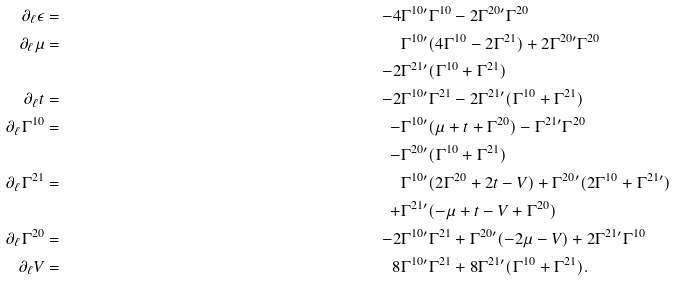Convert formula to latex. <formula><loc_0><loc_0><loc_500><loc_500>\partial _ { \ell } \epsilon & = \, & \, - 4 & \Gamma ^ { 1 0 \prime } \Gamma ^ { 1 0 } - 2 \Gamma ^ { 2 0 \prime } \Gamma ^ { 2 0 } \\ \partial _ { \ell } \mu & = \, & \, & \Gamma ^ { 1 0 \prime } ( 4 \Gamma ^ { 1 0 } - 2 \Gamma ^ { 2 1 } ) + 2 \Gamma ^ { 2 0 \prime } \Gamma ^ { 2 0 } \\ & \, & \, - 2 & \Gamma ^ { 2 1 \prime } ( \Gamma ^ { 1 0 } + \Gamma ^ { 2 1 } ) \\ \partial _ { \ell } t & = \, & \, - 2 & \Gamma ^ { 1 0 \prime } \Gamma ^ { 2 1 } - 2 \Gamma ^ { 2 1 \prime } ( \Gamma ^ { 1 0 } + \Gamma ^ { 2 1 } ) \\ \partial _ { \ell } \Gamma ^ { 1 0 } & = \, & \, - & \Gamma ^ { 1 0 \prime } ( \mu + t + \Gamma ^ { 2 0 } ) - \Gamma ^ { 2 1 \prime } \Gamma ^ { 2 0 } \\ & \, & \, - & \Gamma ^ { 2 0 \prime } ( \Gamma ^ { 1 0 } + \Gamma ^ { 2 1 } ) \\ \partial _ { \ell } \Gamma ^ { 2 1 } & = \, & \, & \Gamma ^ { 1 0 \prime } ( 2 \Gamma ^ { 2 0 } + 2 t - V ) + \Gamma ^ { 2 0 \prime } ( 2 \Gamma ^ { 1 0 } + \Gamma ^ { 2 1 \prime } ) \\ & \, & \, + & \Gamma ^ { 2 1 \prime } ( - \mu + t - V + \Gamma ^ { 2 0 } ) \\ \partial _ { \ell } \Gamma ^ { 2 0 } & = \, & \, - 2 & \Gamma ^ { 1 0 \prime } \Gamma ^ { 2 1 } + \Gamma ^ { 2 0 \prime } ( - 2 \mu - V ) + 2 \Gamma ^ { 2 1 \prime } \Gamma ^ { 1 0 } \\ \partial _ { \ell } V & = \, & \, 8 & \Gamma ^ { 1 0 \prime } \Gamma ^ { 2 1 } + 8 \Gamma ^ { 2 1 \prime } ( \Gamma ^ { 1 0 } + \Gamma ^ { 2 1 } ) .</formula> 